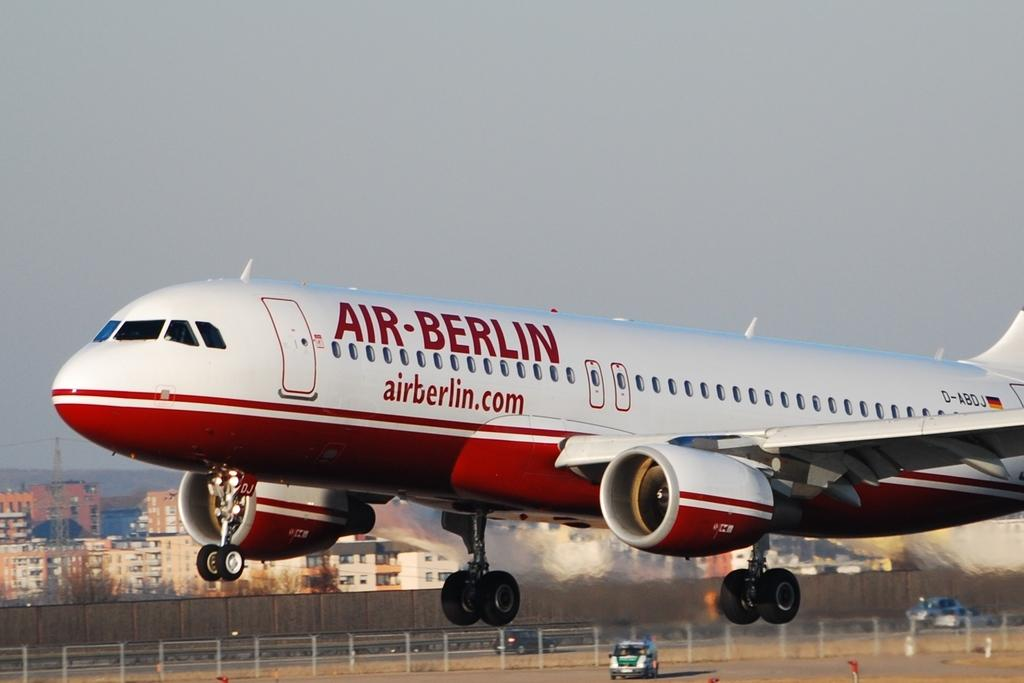<image>
Describe the image concisely. A white and red airplane says Air-Berlin on it. 